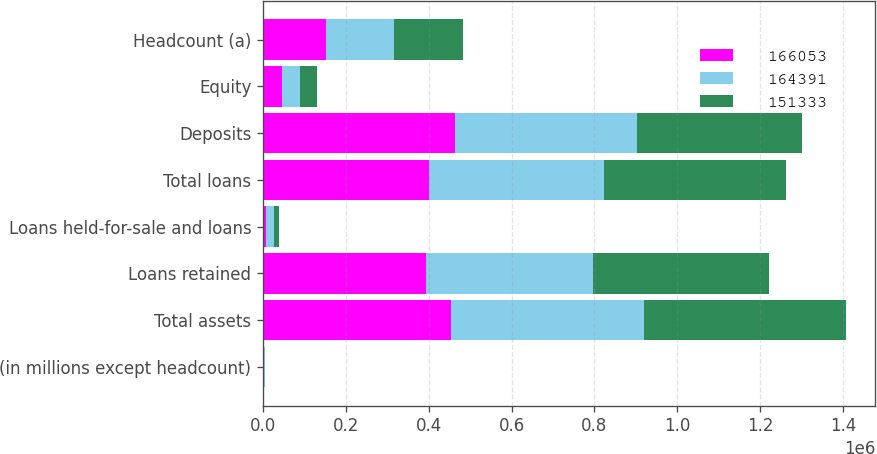Convert chart to OTSL. <chart><loc_0><loc_0><loc_500><loc_500><stacked_bar_chart><ecel><fcel>(in millions except headcount)<fcel>Total assets<fcel>Loans retained<fcel>Loans held-for-sale and loans<fcel>Total loans<fcel>Deposits<fcel>Equity<fcel>Headcount (a)<nl><fcel>166053<fcel>2013<fcel>452929<fcel>393351<fcel>7772<fcel>401123<fcel>464412<fcel>46000<fcel>151333<nl><fcel>164391<fcel>2012<fcel>467282<fcel>402963<fcel>18801<fcel>421764<fcel>438517<fcel>43000<fcel>164391<nl><fcel>151333<fcel>2011<fcel>486697<fcel>425581<fcel>12796<fcel>438377<fcel>397868<fcel>41000<fcel>166053<nl></chart> 